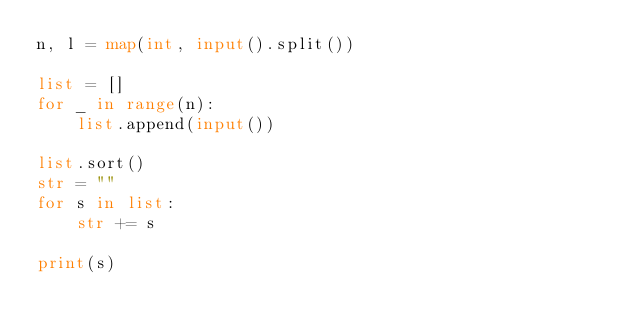Convert code to text. <code><loc_0><loc_0><loc_500><loc_500><_Python_>n, l = map(int, input().split())

list = []
for _ in range(n):
    list.append(input())

list.sort()
str = ""
for s in list:
    str += s

print(s)</code> 